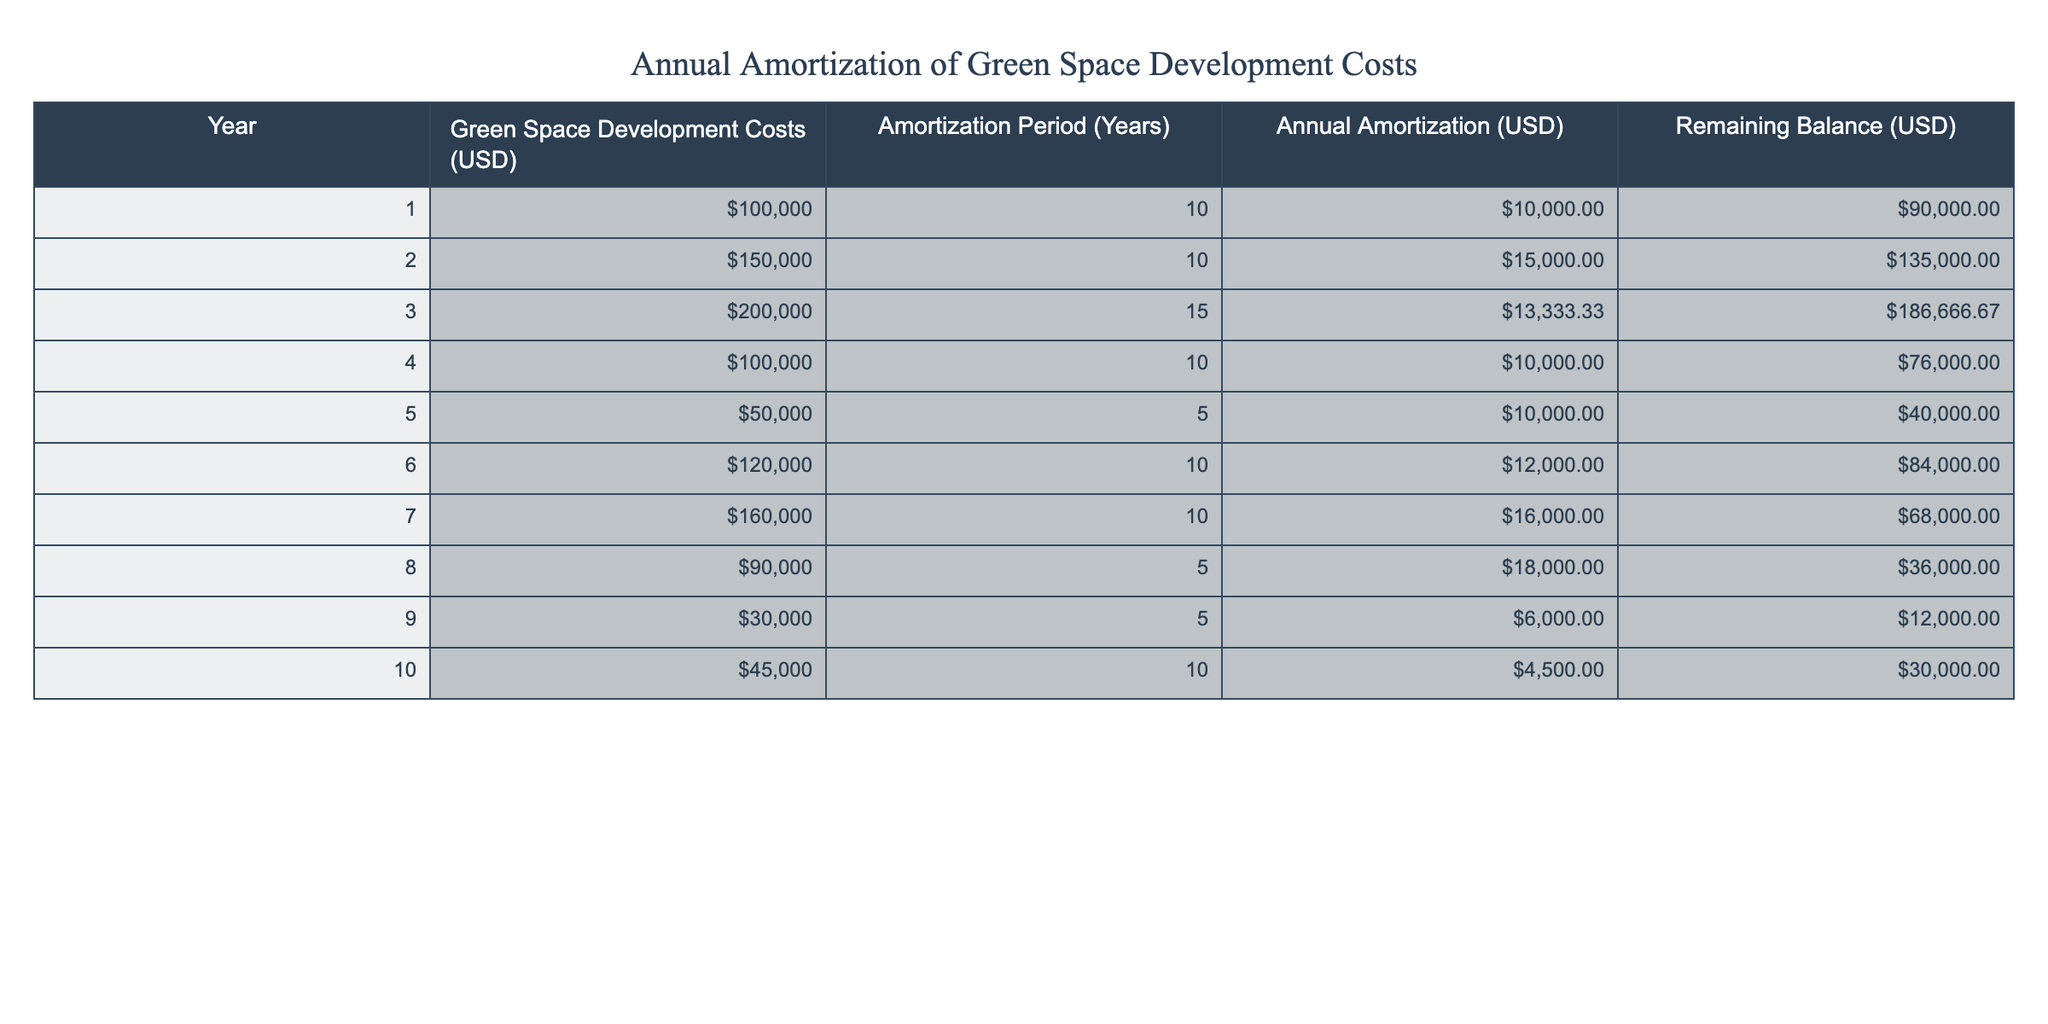What is the total amount spent on green space development in year 3? In year 3, the green space development costs are listed as 200000 USD.
Answer: 200000 USD What is the remaining balance after the first year? The remaining balance after the first year is shown as 90000 USD.
Answer: 90000 USD How much was the annual amortization in year 6? In year 6, the annual amortization is indicated as 12000 USD.
Answer: 12000 USD Is the annual amortization higher in year 2 than in year 4? In year 2, the annual amortization is 15000 USD, while in year 4, it is 10000 USD. Since 15000 is greater than 10000, the statement is true.
Answer: Yes What is the average annual amortization over the ten years? To find the average, sum the annual amortizations: 10000 + 15000 + 13333.33 + 10000 + 10000 + 12000 + 16000 + 18000 + 6000 + 4500 = 109833.33. Then divide by 10 (number of years): 109833.33 / 10 = 10983.33.
Answer: 10983.33 In which year is the remaining balance lowest? Looking through the remaining balances, year 9 shows a lowest remaining balance of 12000 USD.
Answer: Year 9 What is the difference in annual amortization between year 8 and year 9? Year 8 has an annual amortization of 18000 USD, and year 9 has 6000 USD. The difference is calculated as 18000 - 6000 = 12000.
Answer: 12000 Did the green space development costs increase or decrease from year 4 to year 5? In year 4, the costs are 100000 USD, which decreases to 50000 USD in year 5, meaning there is a decrease of 50000 USD.
Answer: Decrease What is the total remaining balance after year 10? After year 10, the remaining balance is shown as 30000 USD.
Answer: 30000 USD 